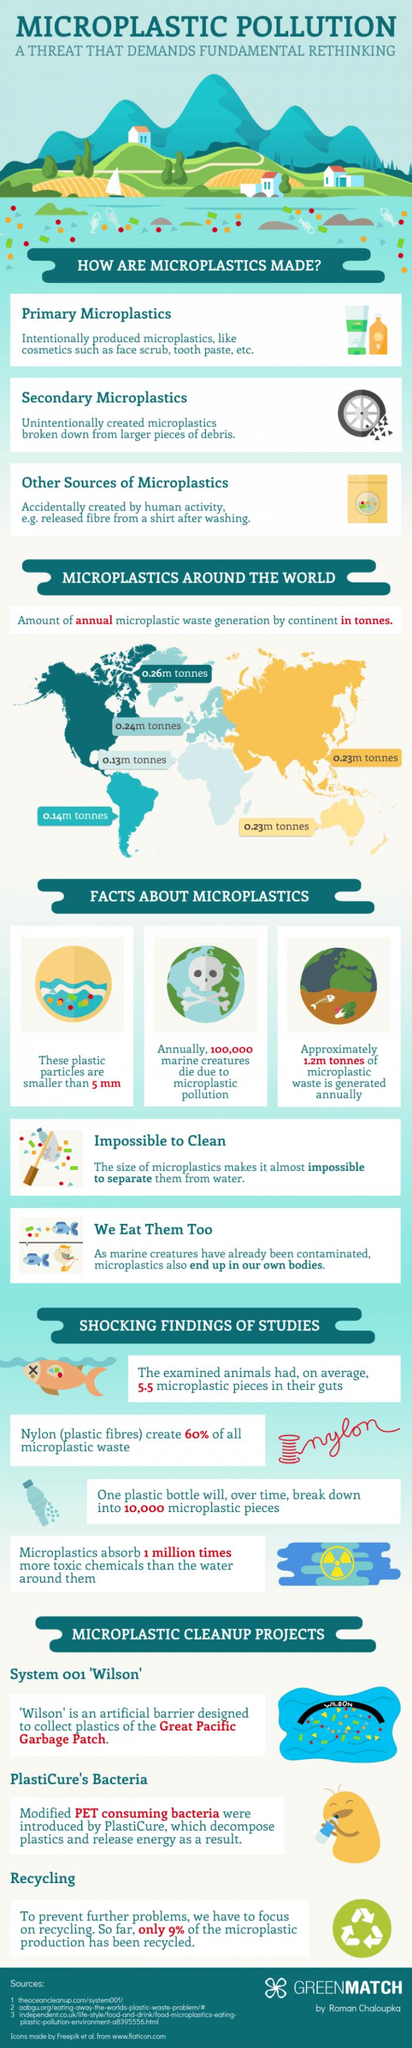Specify some key components in this picture. Microplastics absorb more toxic chemicals than water, according to research. Three microplastics cleanup projects that have been proposed or are currently underway include System 001 'Wilson', which involves the use of bacteria to remove plastic debris from the ocean, Plasticure's project, which aims to recycle microplastics into usable materials, and a beach cleanup program in San Francisco that focuses on removing plastic debris from shorelines. Nylon is a source of microplastic waste. According to estimates, a significant portion of microplastic production has not been recycled, with 91% of it remaining unrecycled. Micro plastic particles with a size of approximately 5 millimeters have been observed. 